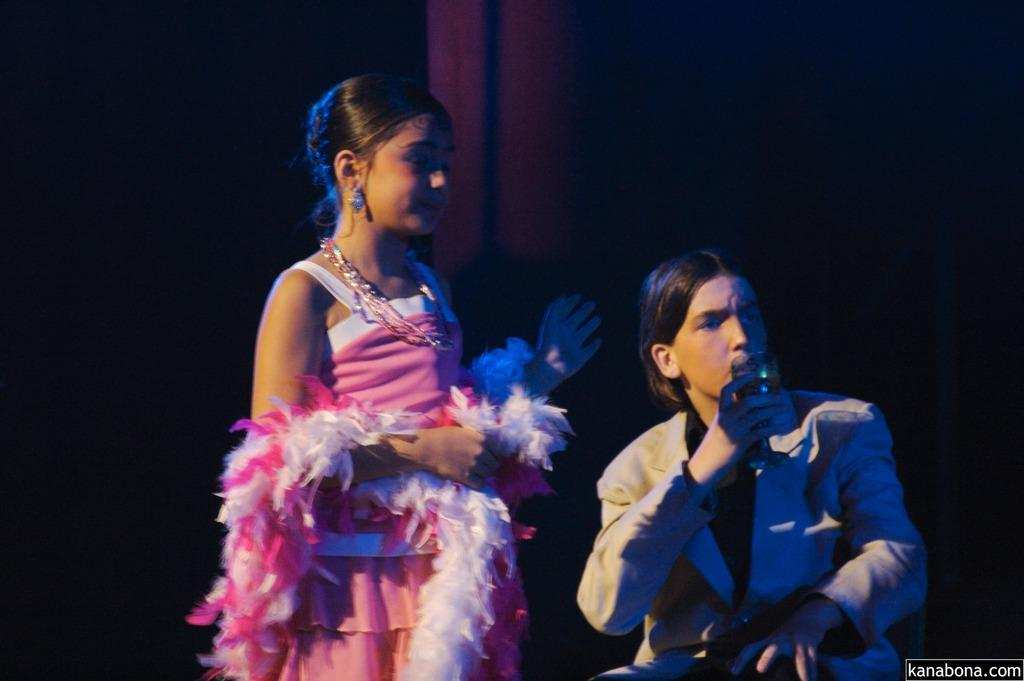How many people are in the image? There are two persons in the image. What is one of the persons holding in his hand? One of the persons is holding a glass with his hand. What can be observed about the background of the image? The background of the image is dark. Can you tell me how many beetles are crawling on the middle person in the image? There is no middle person in the image, and no beetles are present. 